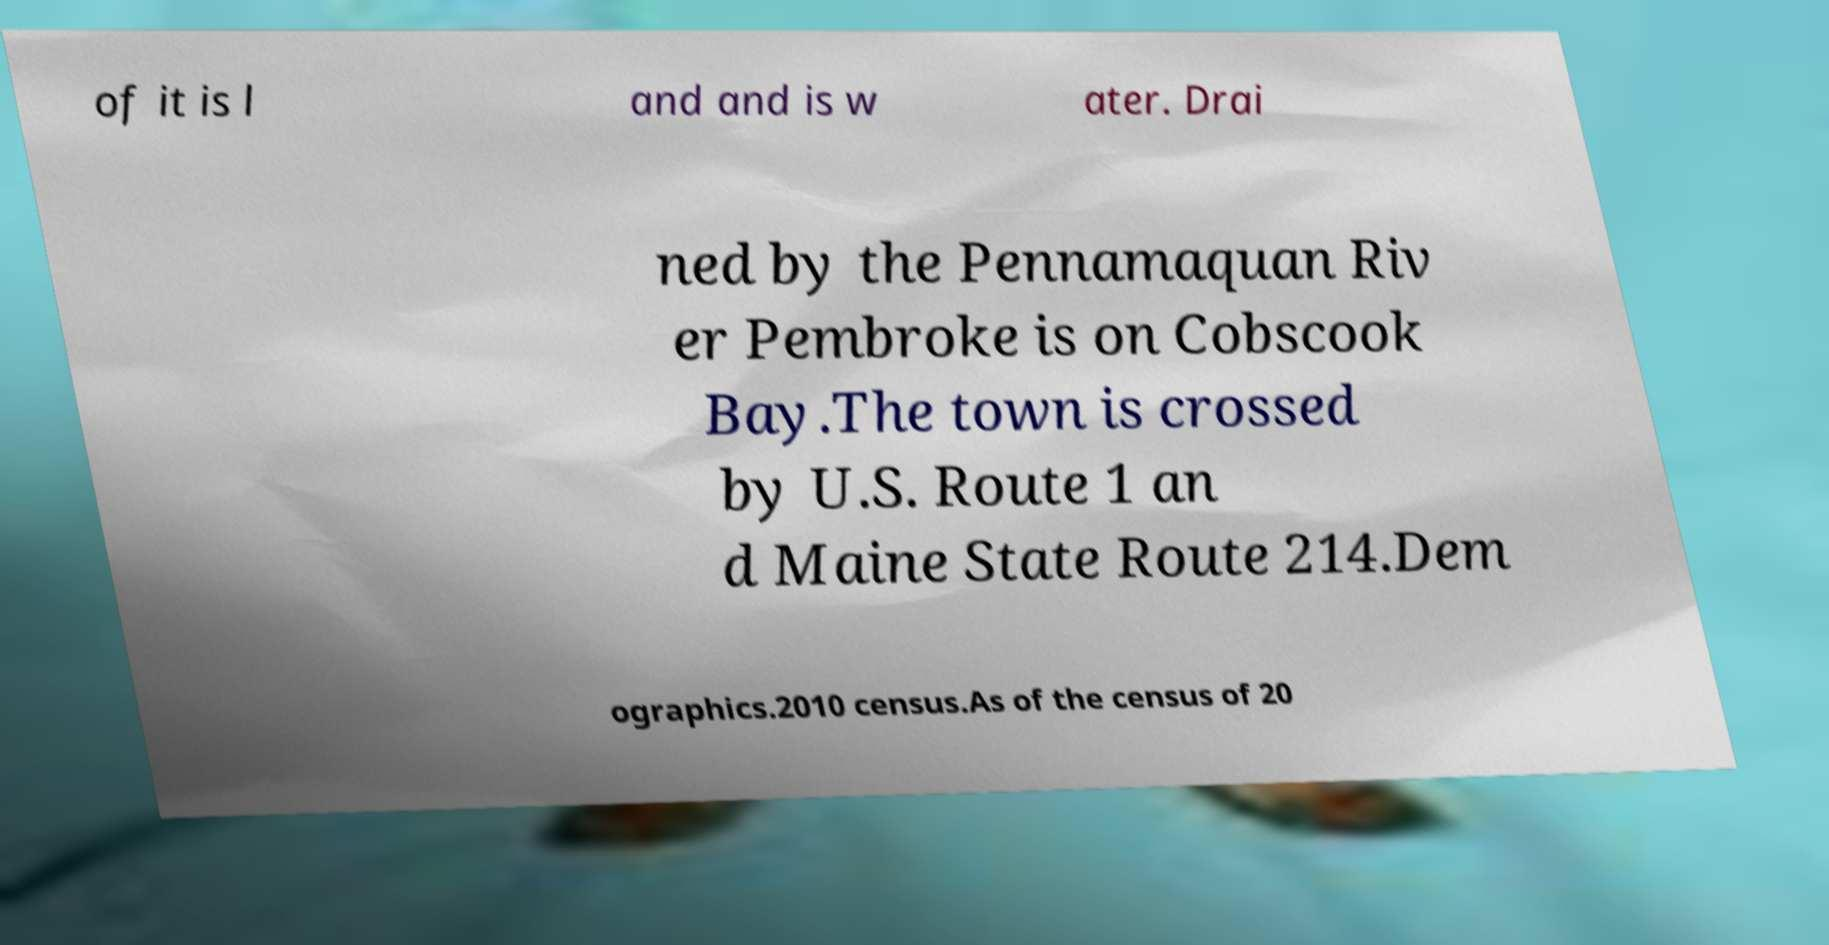What messages or text are displayed in this image? I need them in a readable, typed format. of it is l and and is w ater. Drai ned by the Pennamaquan Riv er Pembroke is on Cobscook Bay.The town is crossed by U.S. Route 1 an d Maine State Route 214.Dem ographics.2010 census.As of the census of 20 